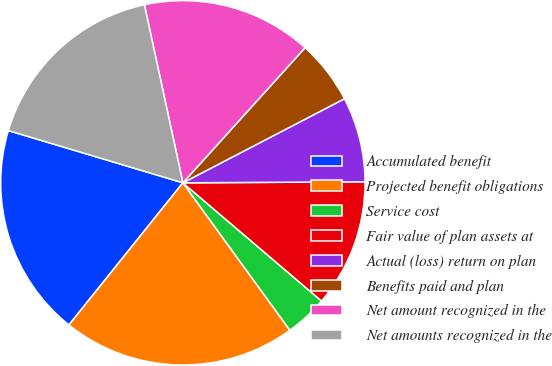Convert chart. <chart><loc_0><loc_0><loc_500><loc_500><pie_chart><fcel>Accumulated benefit<fcel>Projected benefit obligations<fcel>Service cost<fcel>Fair value of plan assets at<fcel>Actual (loss) return on plan<fcel>Benefits paid and plan<fcel>Net amount recognized in the<fcel>Net amounts recognized in the<nl><fcel>18.87%<fcel>20.75%<fcel>3.77%<fcel>11.32%<fcel>7.55%<fcel>5.66%<fcel>15.09%<fcel>16.98%<nl></chart> 